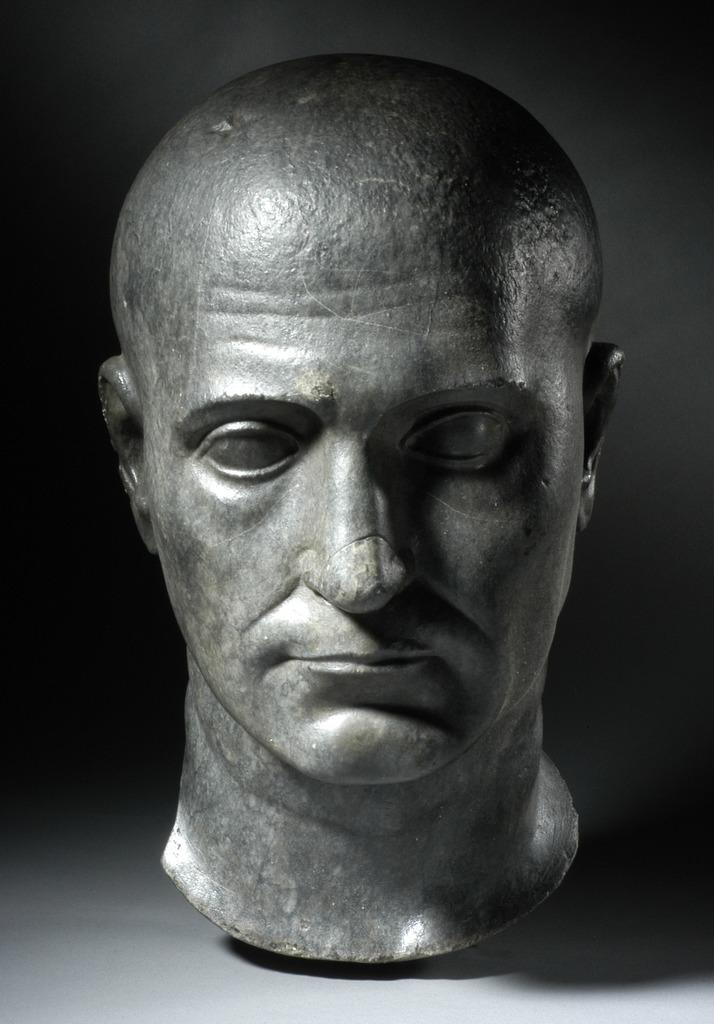What is the main subject of the image? The main subject of the image is a sculpture of a person's face on the ground. What can be observed about the background of the image? The background of the image is dark. What type of alarm is going off in the image? There is no alarm present in the image. Can you describe the ball that is being juggled in the image? There is no ball or juggling activity present in the image. 